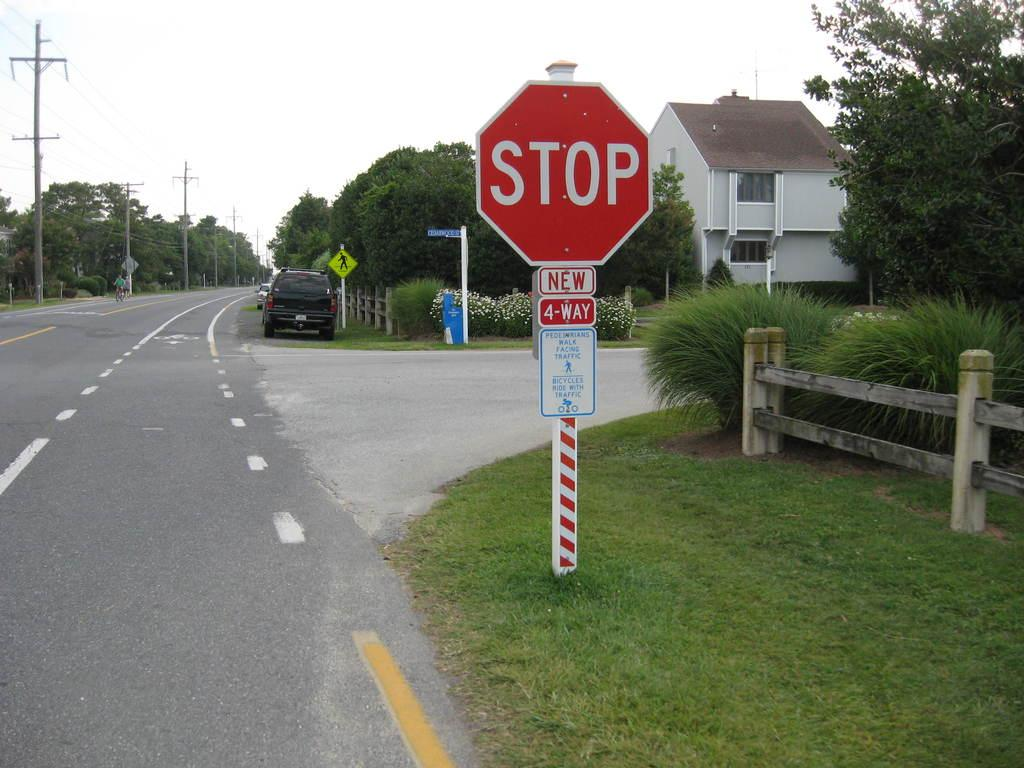<image>
Provide a brief description of the given image. On the side of the road a STOP sign is sitting at a 4-WAY intersection. 